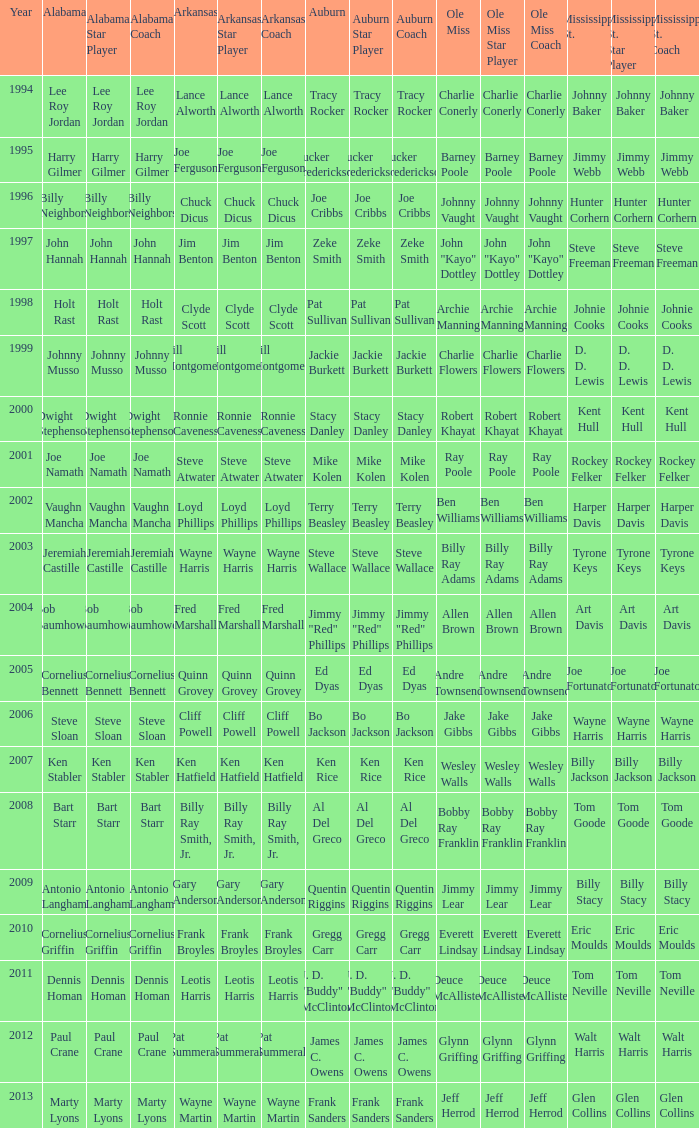Who was the Mississippi State player associated with Cornelius Bennett? Joe Fortunato. 